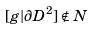<formula> <loc_0><loc_0><loc_500><loc_500>[ g | \partial D ^ { 2 } ] \notin N</formula> 